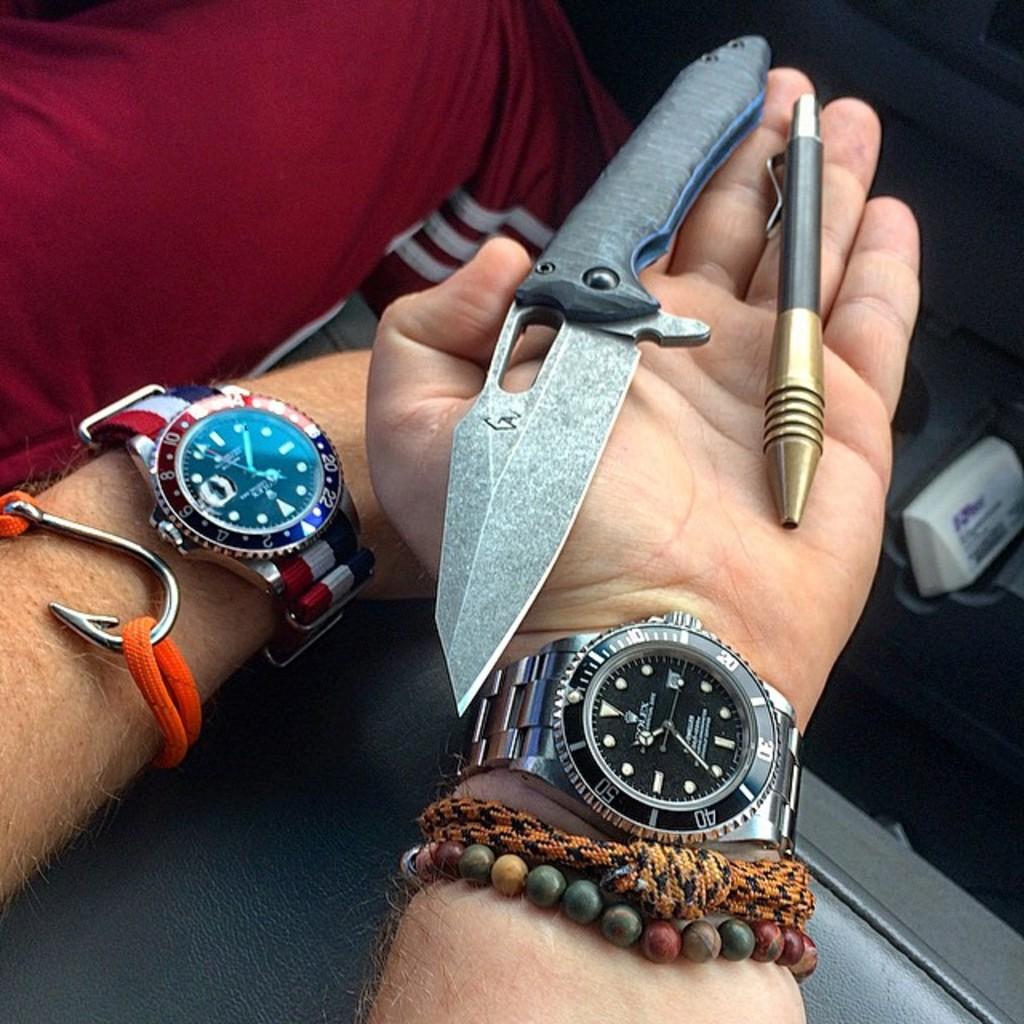What is the brand of both the watches?
Provide a succinct answer. Rolex. What time are the watches pointing to?
Offer a very short reply. 10:35. 